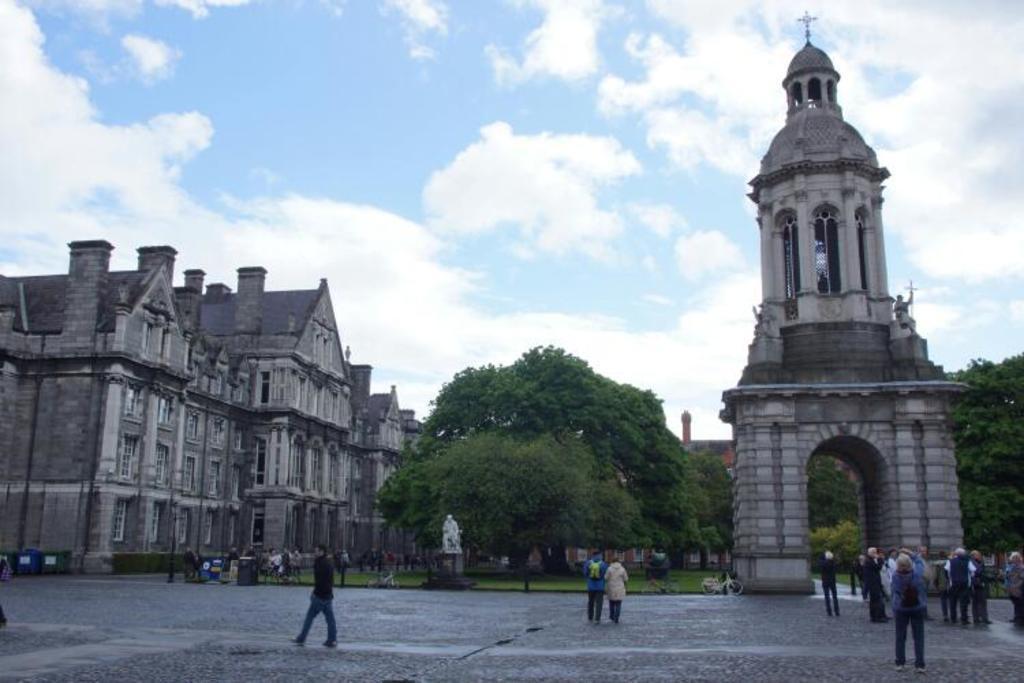In one or two sentences, can you explain what this image depicts? In this picture we can see the building with roof tiles. On the right side we can see the tower. In the front bottom side there are some people standing on the road and looking to the buildings. 